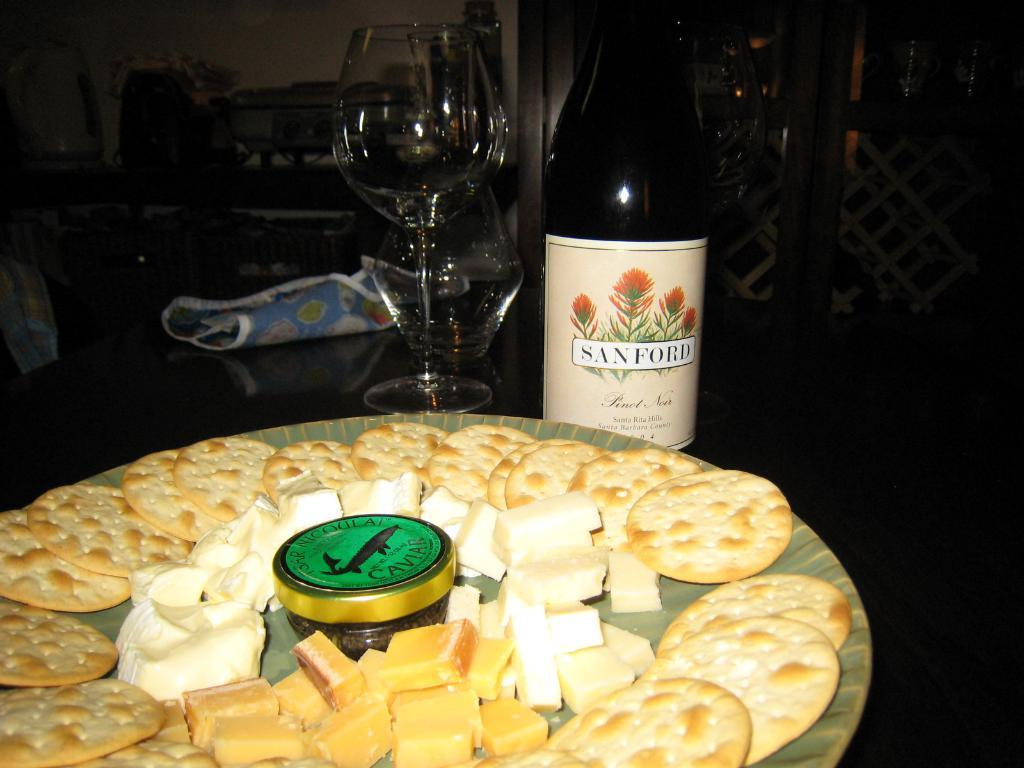<image>
Write a terse but informative summary of the picture. Cheese and biscuits in front of a bottle that reads Sanford. 